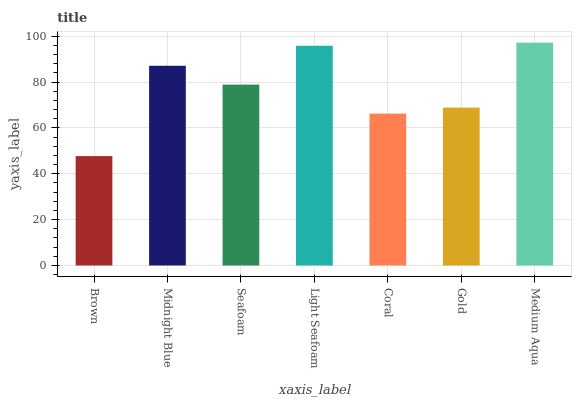Is Midnight Blue the minimum?
Answer yes or no. No. Is Midnight Blue the maximum?
Answer yes or no. No. Is Midnight Blue greater than Brown?
Answer yes or no. Yes. Is Brown less than Midnight Blue?
Answer yes or no. Yes. Is Brown greater than Midnight Blue?
Answer yes or no. No. Is Midnight Blue less than Brown?
Answer yes or no. No. Is Seafoam the high median?
Answer yes or no. Yes. Is Seafoam the low median?
Answer yes or no. Yes. Is Brown the high median?
Answer yes or no. No. Is Light Seafoam the low median?
Answer yes or no. No. 